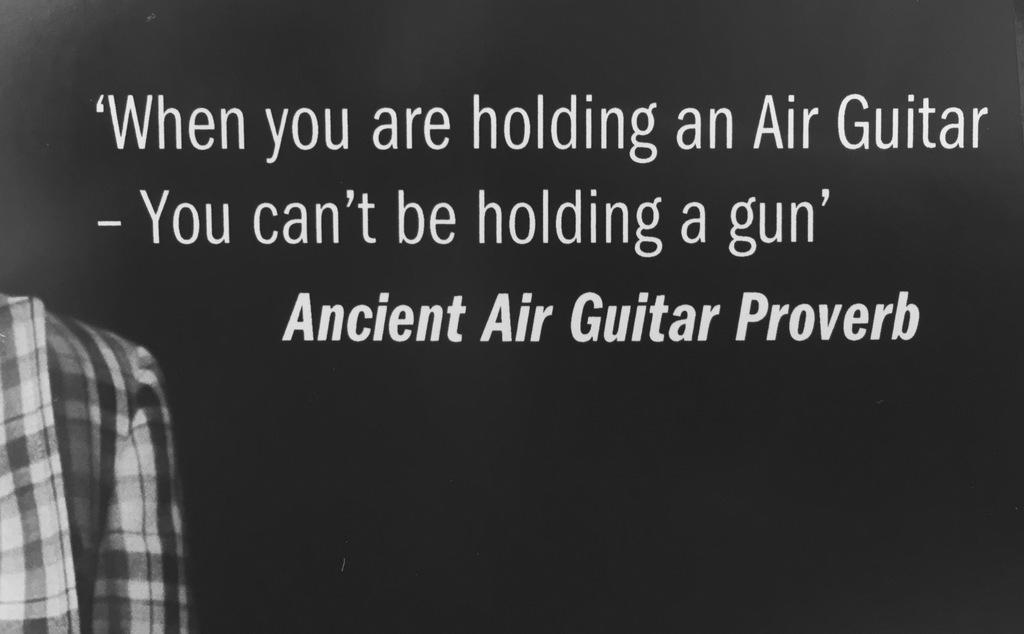What is written on the black surface in the image? The provided facts do not specify the content of the text on the black surface. What can be seen on the left side of the image? There is cloth on the left side of the image. What type of love is being expressed in the image? There is no indication of love or any emotional expression in the image, as it only features text on a black surface and cloth on the left side. What territory is depicted in the image? The image does not depict any territory or geographical location; it only contains text on a black surface and cloth on the left side. 